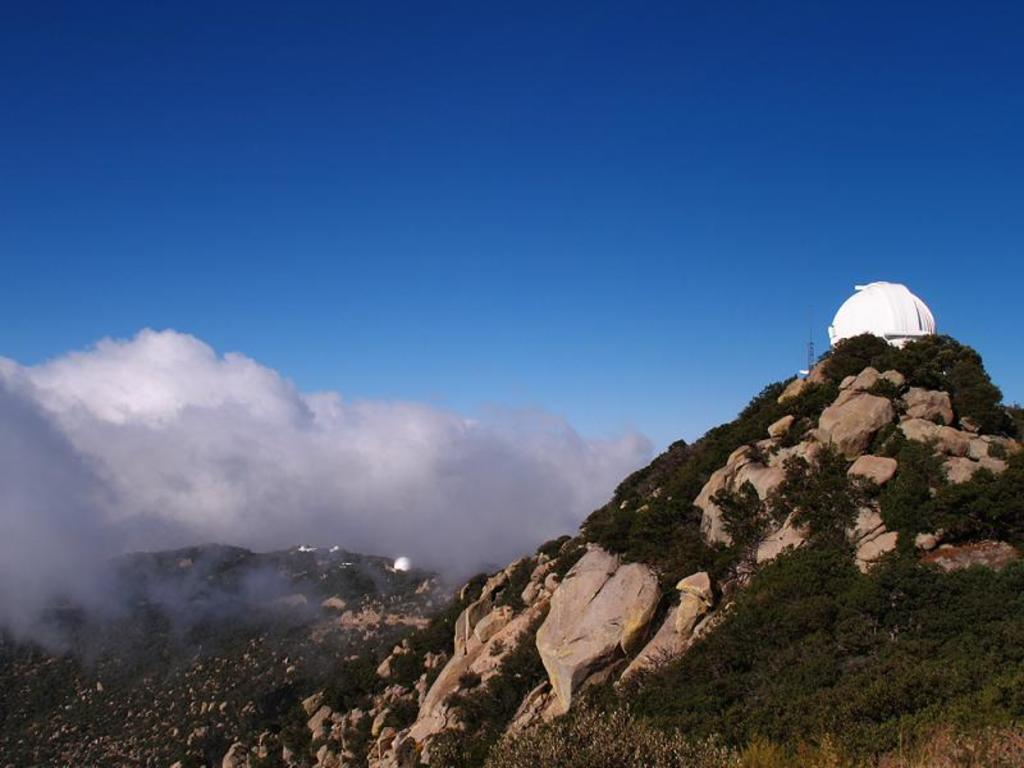What type of vegetation can be seen on the mountains in the image? There are trees on the rocky mountains in the image. What is located on the top of the mountain? There is a structure on the top of the mountain. What is visible in the sky in the image? There are clouds in the sky. What type of cream can be seen being used to build the structure on the mountain? There is no cream present in the image, and it is not being used to build the structure on the mountain. What tool is being used to hammer the structure on the mountain? There is no hammer or any construction activity depicted in the image. 